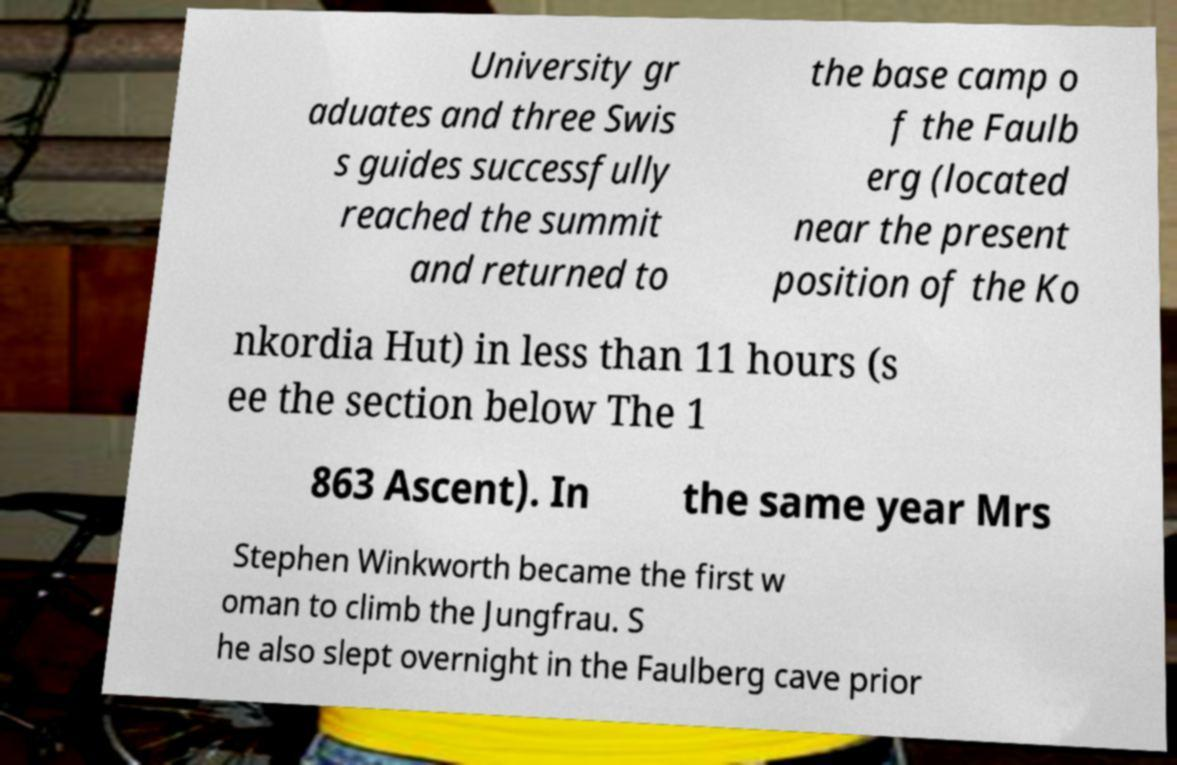Can you accurately transcribe the text from the provided image for me? University gr aduates and three Swis s guides successfully reached the summit and returned to the base camp o f the Faulb erg (located near the present position of the Ko nkordia Hut) in less than 11 hours (s ee the section below The 1 863 Ascent). In the same year Mrs Stephen Winkworth became the first w oman to climb the Jungfrau. S he also slept overnight in the Faulberg cave prior 